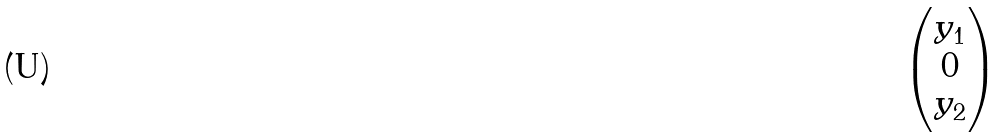Convert formula to latex. <formula><loc_0><loc_0><loc_500><loc_500>\begin{pmatrix} y _ { 1 } \\ 0 \\ y _ { 2 } \end{pmatrix}</formula> 